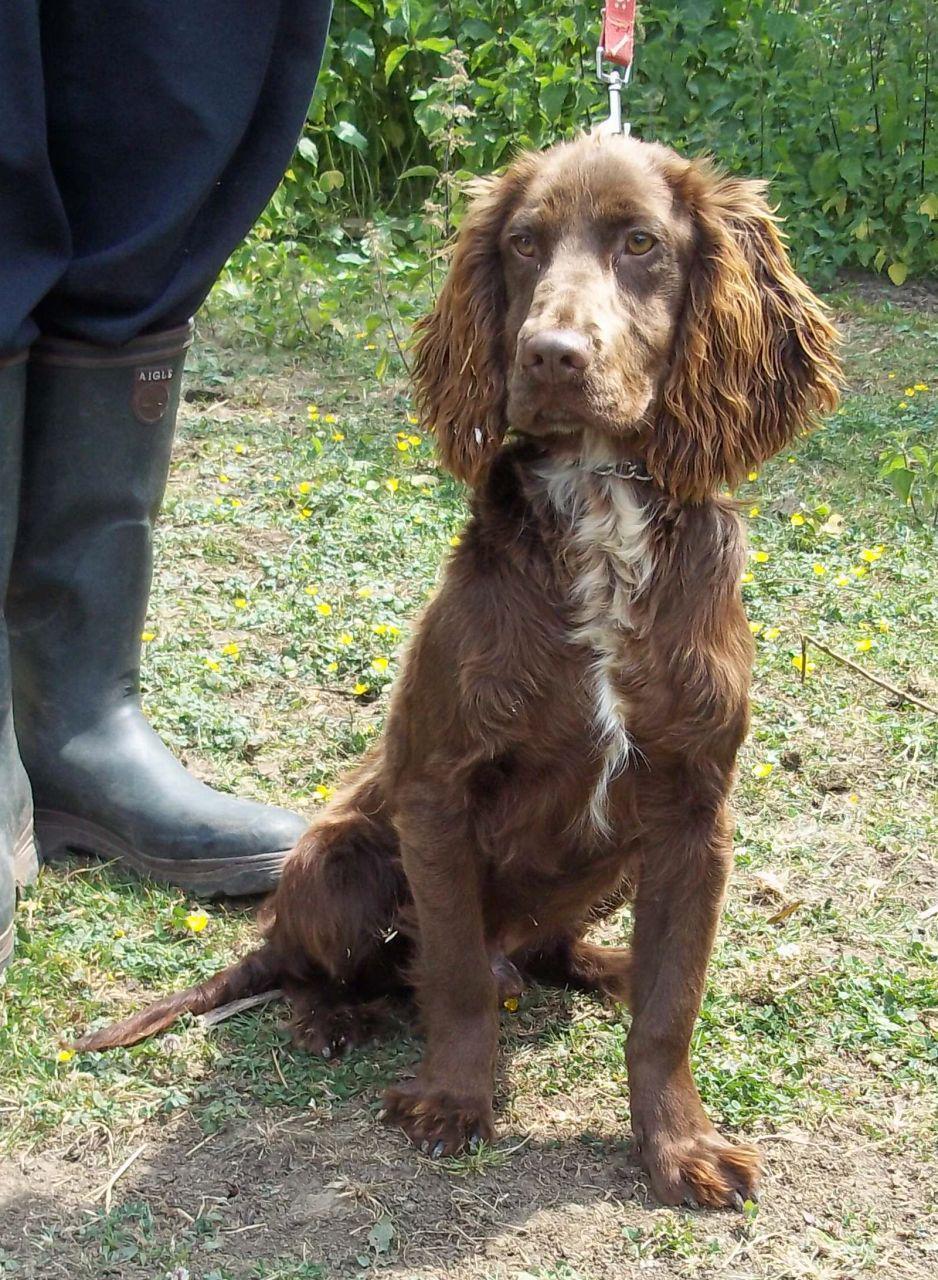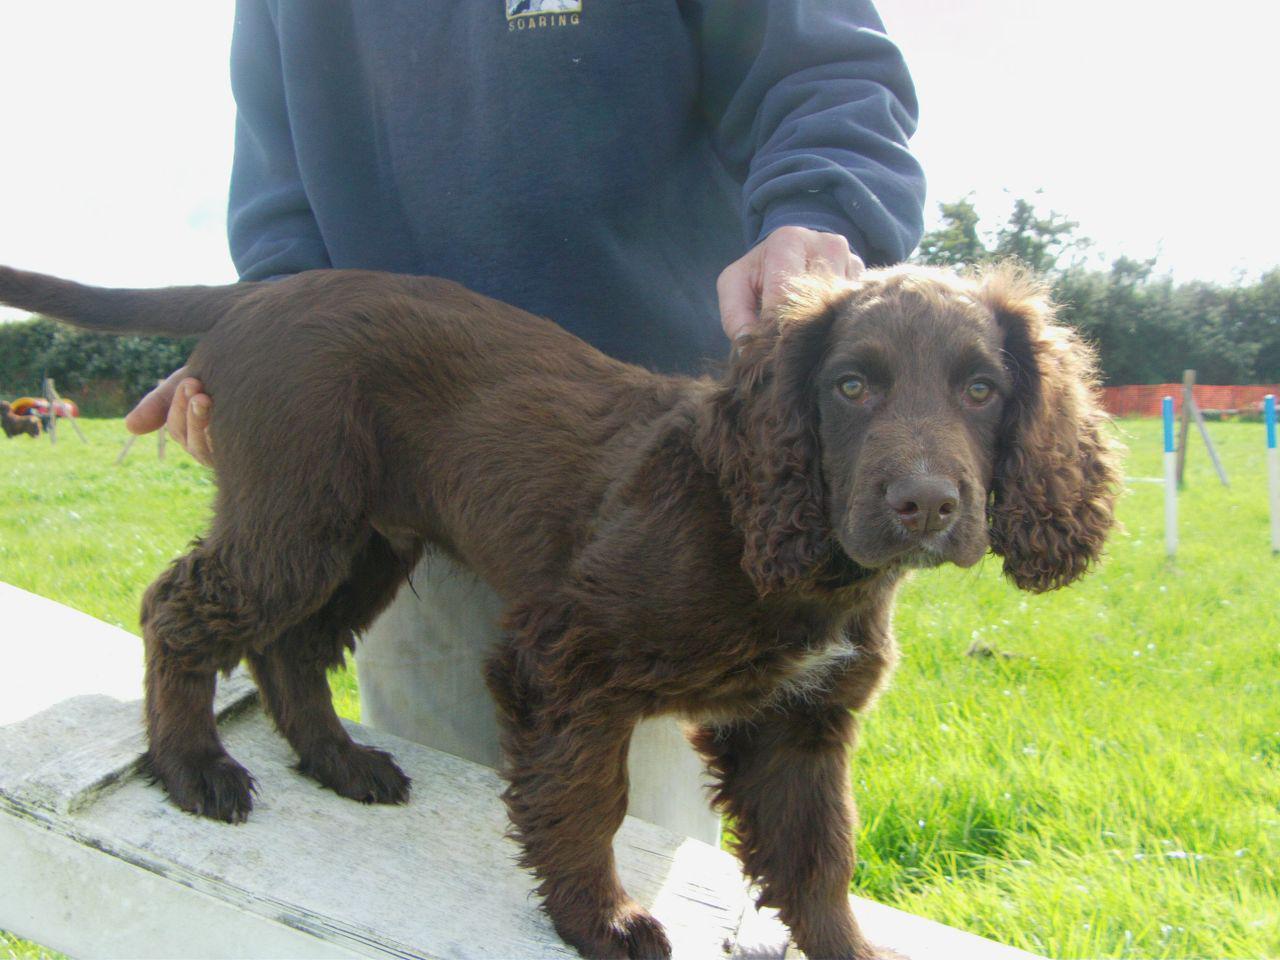The first image is the image on the left, the second image is the image on the right. Given the left and right images, does the statement "The left image contains one dog, a chocolate-brown spaniel with a leash extending from its neck." hold true? Answer yes or no. Yes. The first image is the image on the left, the second image is the image on the right. For the images displayed, is the sentence "The dog in the image on the left is on a leash." factually correct? Answer yes or no. Yes. 